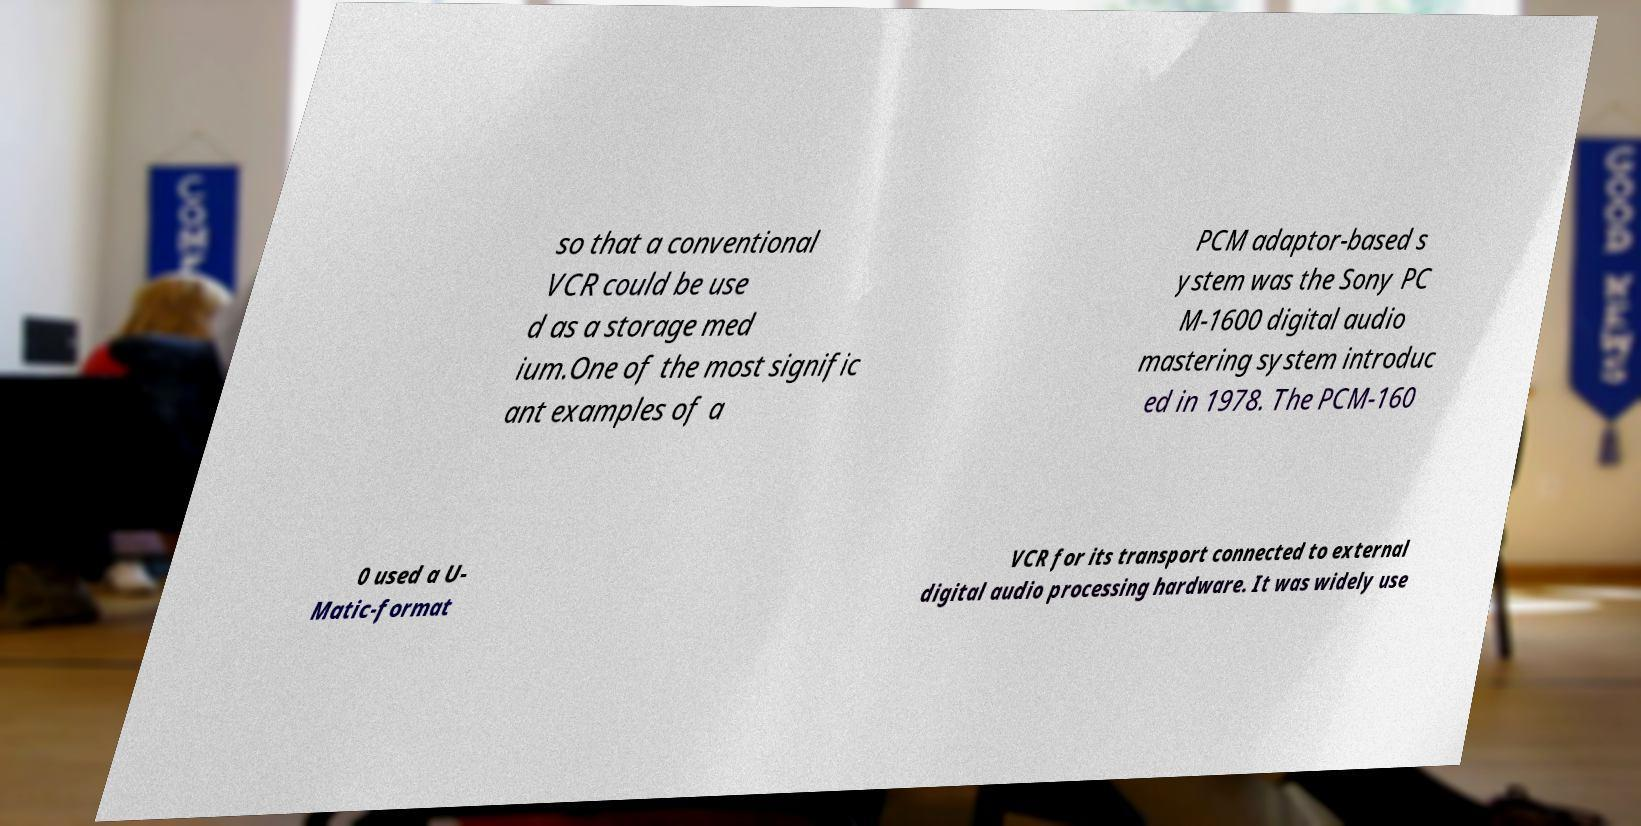Please read and relay the text visible in this image. What does it say? so that a conventional VCR could be use d as a storage med ium.One of the most signific ant examples of a PCM adaptor-based s ystem was the Sony PC M-1600 digital audio mastering system introduc ed in 1978. The PCM-160 0 used a U- Matic-format VCR for its transport connected to external digital audio processing hardware. It was widely use 